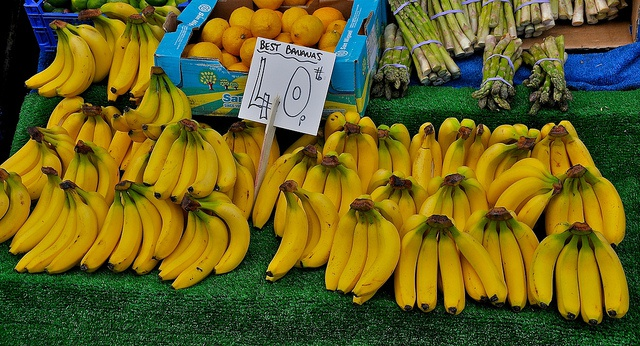Describe the objects in this image and their specific colors. I can see banana in black, olive, and orange tones, banana in black, olive, and gold tones, banana in black, olive, and orange tones, banana in black, olive, and orange tones, and banana in black, olive, and gold tones in this image. 